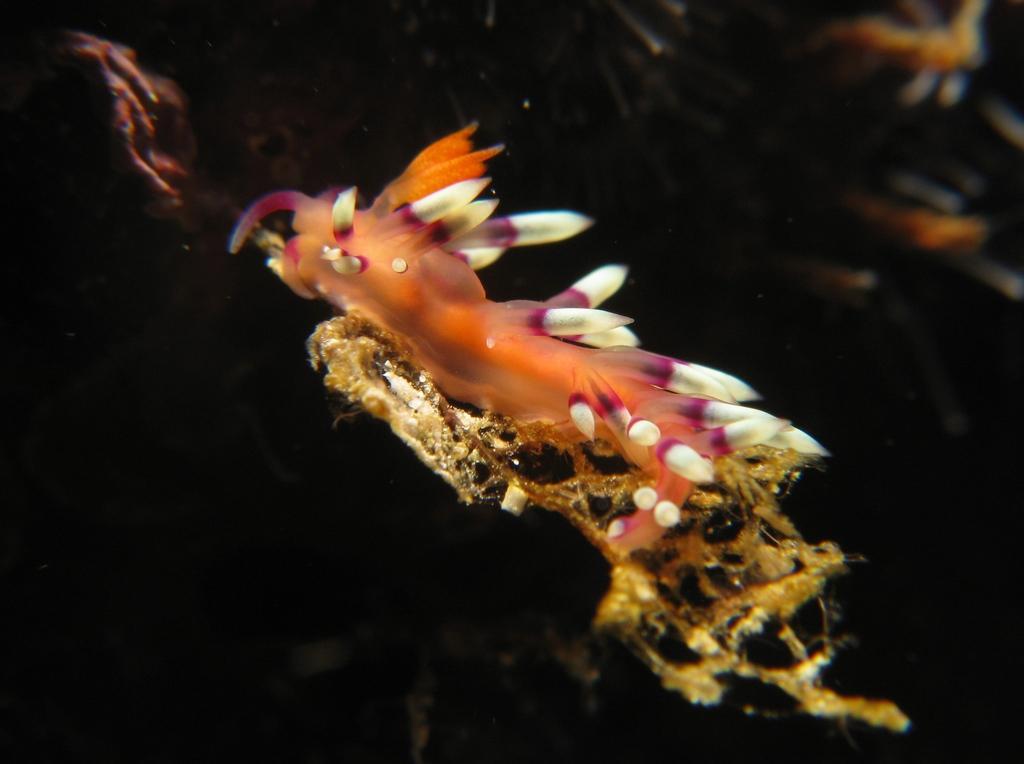In one or two sentences, can you explain what this image depicts? In this image we can see a water animal. 